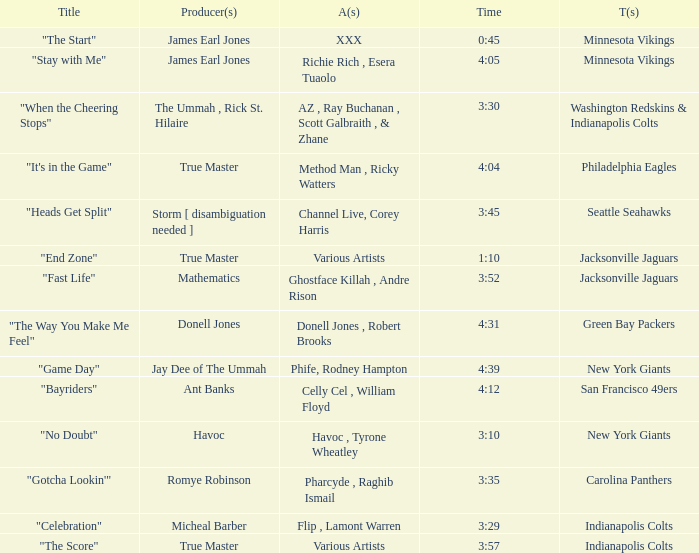Who produced "Fast Life"? Mathematics. 